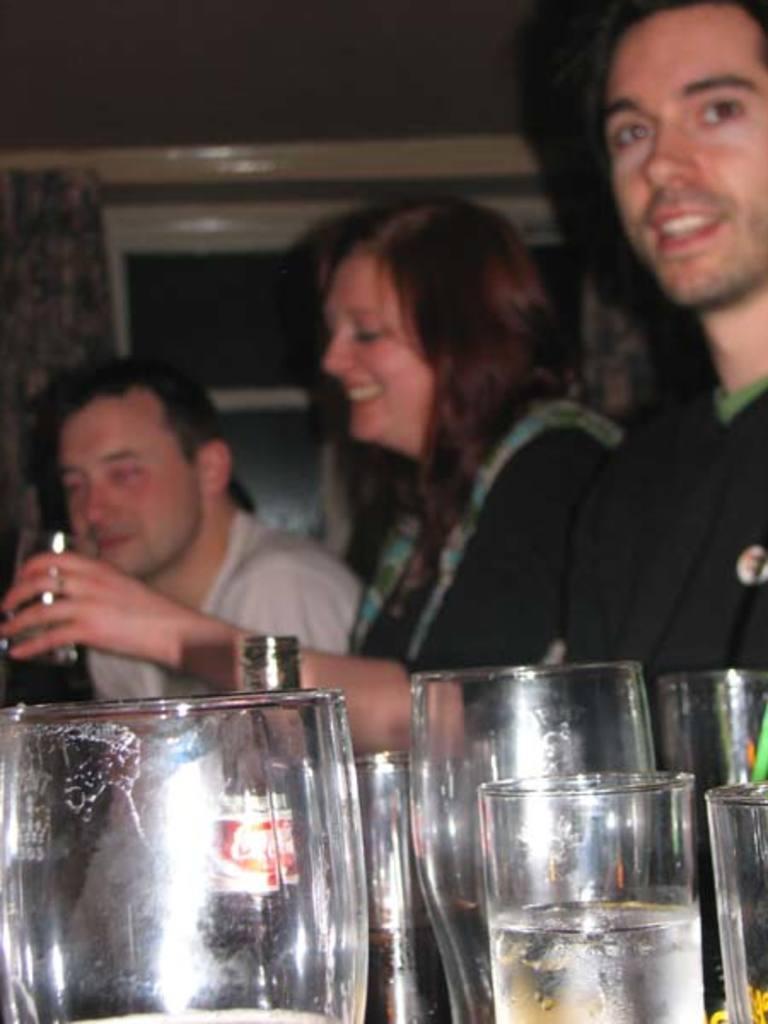Describe this image in one or two sentences. In the foreground of this picture, there are few glasses, bottles. In the background, there are persons and a wall. 